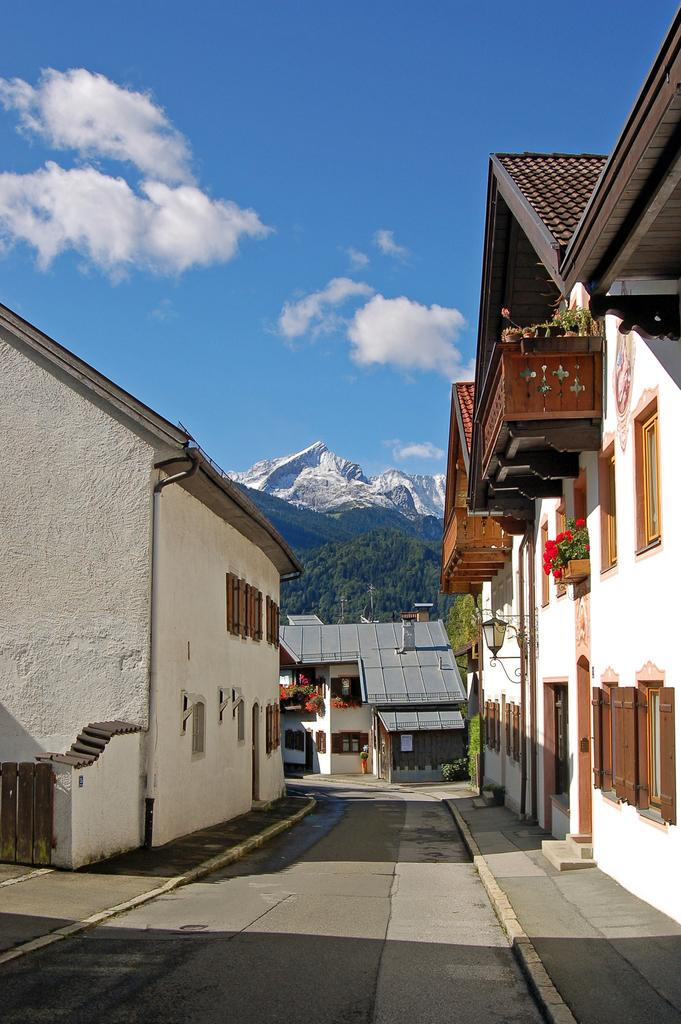What type of pathway is visible in the image? There is a road in the image. What structures can be seen alongside the road? There are buildings in the image. What type of vegetation is present in the image? There are flowers on plants and trees in the image. What can be seen in the distance in the image? There are mountains in the background of the image. What is the weather like in the image? The sky is cloudy in the image. Can you tell me how many gloves are being worn by the trees in the image? There are no gloves present in the image; the trees are not wearing any accessories. 